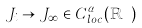<formula> <loc_0><loc_0><loc_500><loc_500>J _ { i } \rightarrow J _ { \infty } \in C _ { l o c } ^ { \alpha } ( \mathbb { R ^ { n } } )</formula> 